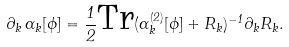<formula> <loc_0><loc_0><loc_500><loc_500>\partial _ { k } \, \Gamma _ { k } [ \phi ] = \frac { 1 } { 2 } \text {Tr} ( \Gamma _ { k } ^ { ( 2 ) } [ \phi ] + R _ { k } ) ^ { - 1 } \partial _ { k } R _ { k } .</formula> 